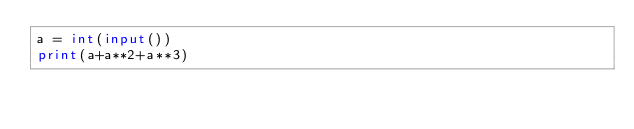<code> <loc_0><loc_0><loc_500><loc_500><_Python_>a = int(input())
print(a+a**2+a**3)</code> 